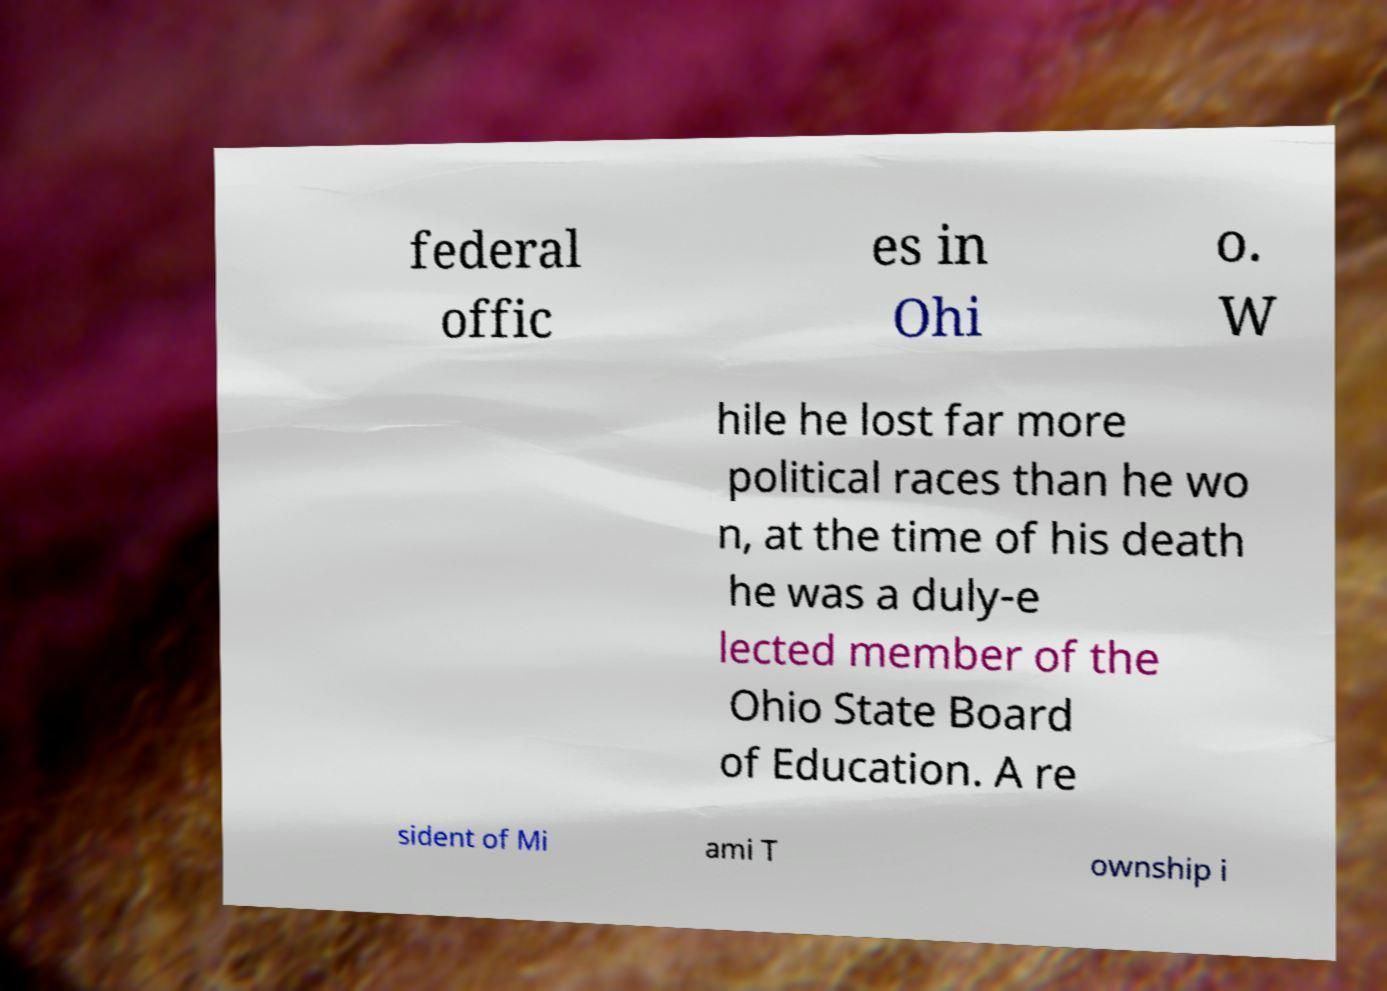Could you extract and type out the text from this image? federal offic es in Ohi o. W hile he lost far more political races than he wo n, at the time of his death he was a duly-e lected member of the Ohio State Board of Education. A re sident of Mi ami T ownship i 